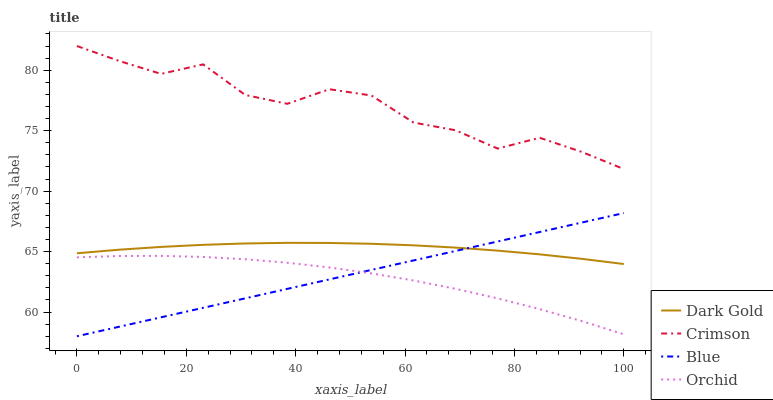Does Orchid have the minimum area under the curve?
Answer yes or no. Yes. Does Crimson have the maximum area under the curve?
Answer yes or no. Yes. Does Blue have the minimum area under the curve?
Answer yes or no. No. Does Blue have the maximum area under the curve?
Answer yes or no. No. Is Blue the smoothest?
Answer yes or no. Yes. Is Crimson the roughest?
Answer yes or no. Yes. Is Orchid the smoothest?
Answer yes or no. No. Is Orchid the roughest?
Answer yes or no. No. Does Blue have the lowest value?
Answer yes or no. Yes. Does Orchid have the lowest value?
Answer yes or no. No. Does Crimson have the highest value?
Answer yes or no. Yes. Does Blue have the highest value?
Answer yes or no. No. Is Blue less than Crimson?
Answer yes or no. Yes. Is Dark Gold greater than Orchid?
Answer yes or no. Yes. Does Orchid intersect Blue?
Answer yes or no. Yes. Is Orchid less than Blue?
Answer yes or no. No. Is Orchid greater than Blue?
Answer yes or no. No. Does Blue intersect Crimson?
Answer yes or no. No. 